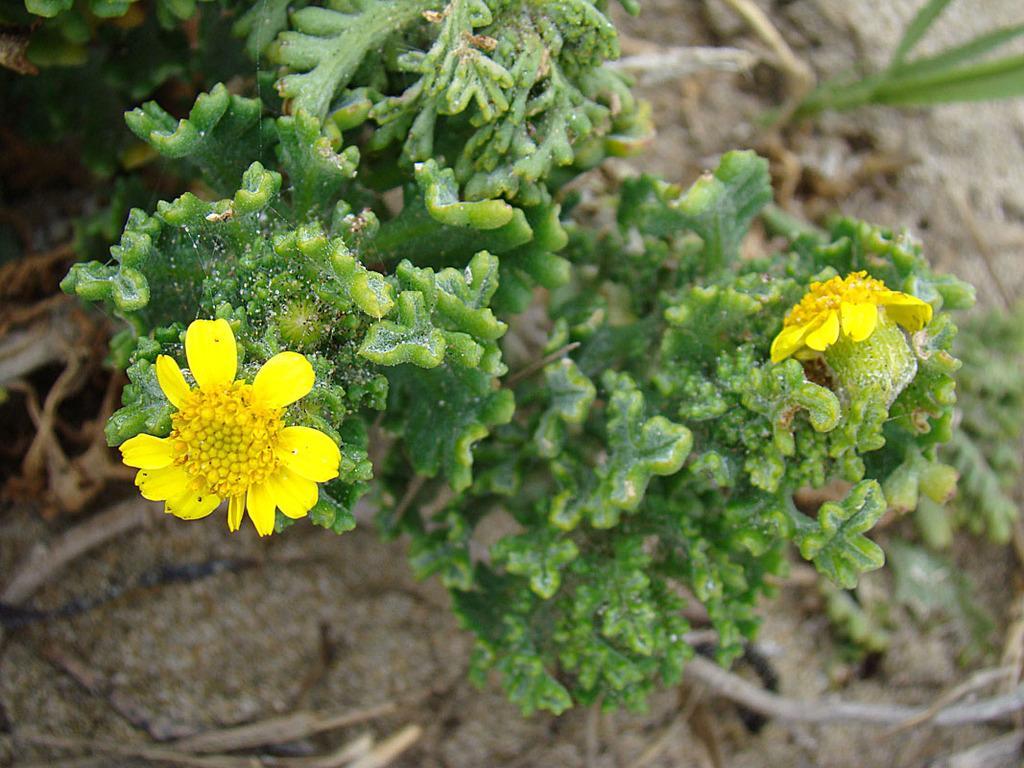Please provide a concise description of this image. In the foreground of this picture, there is a plant to which two yellow colored flowers are present to it. In the background, there are sticks and the sand. 